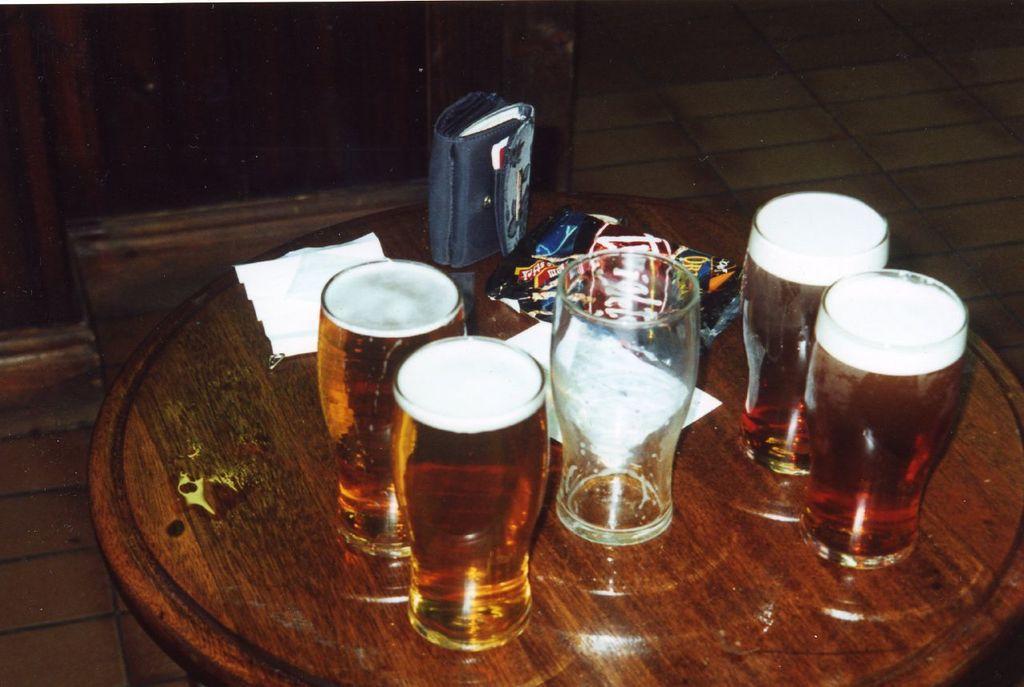In one or two sentences, can you explain what this image depicts? There are five glasses, four of them are filled with drink on the wooden table. Which is on the floor. 